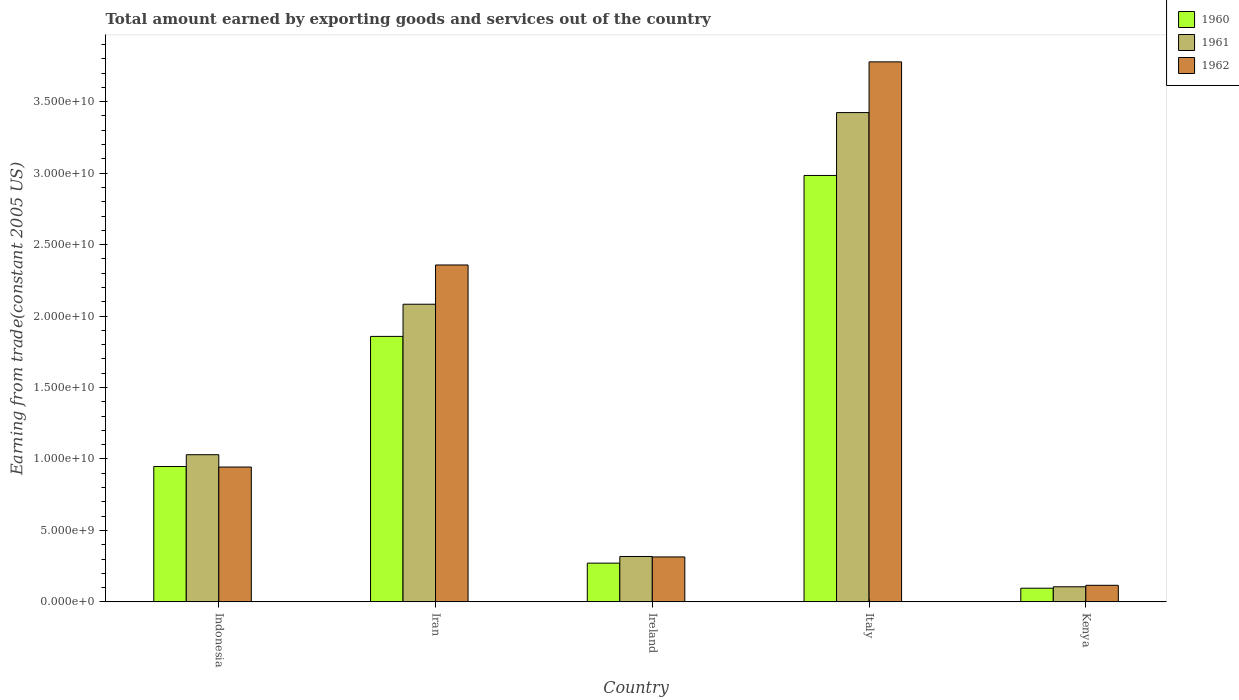How many different coloured bars are there?
Offer a very short reply. 3. How many groups of bars are there?
Offer a very short reply. 5. Are the number of bars on each tick of the X-axis equal?
Offer a very short reply. Yes. How many bars are there on the 4th tick from the right?
Offer a terse response. 3. What is the label of the 3rd group of bars from the left?
Your answer should be very brief. Ireland. What is the total amount earned by exporting goods and services in 1960 in Indonesia?
Make the answer very short. 9.47e+09. Across all countries, what is the maximum total amount earned by exporting goods and services in 1961?
Give a very brief answer. 3.42e+1. Across all countries, what is the minimum total amount earned by exporting goods and services in 1962?
Keep it short and to the point. 1.16e+09. In which country was the total amount earned by exporting goods and services in 1960 maximum?
Keep it short and to the point. Italy. In which country was the total amount earned by exporting goods and services in 1961 minimum?
Ensure brevity in your answer.  Kenya. What is the total total amount earned by exporting goods and services in 1960 in the graph?
Offer a very short reply. 6.16e+1. What is the difference between the total amount earned by exporting goods and services in 1962 in Iran and that in Kenya?
Your answer should be very brief. 2.24e+1. What is the difference between the total amount earned by exporting goods and services in 1961 in Italy and the total amount earned by exporting goods and services in 1960 in Ireland?
Your answer should be very brief. 3.15e+1. What is the average total amount earned by exporting goods and services in 1961 per country?
Make the answer very short. 1.39e+1. What is the difference between the total amount earned by exporting goods and services of/in 1960 and total amount earned by exporting goods and services of/in 1961 in Indonesia?
Make the answer very short. -8.26e+08. What is the ratio of the total amount earned by exporting goods and services in 1960 in Indonesia to that in Kenya?
Your answer should be compact. 9.91. What is the difference between the highest and the second highest total amount earned by exporting goods and services in 1961?
Ensure brevity in your answer.  1.05e+1. What is the difference between the highest and the lowest total amount earned by exporting goods and services in 1961?
Your answer should be compact. 3.32e+1. What does the 2nd bar from the right in Kenya represents?
Offer a terse response. 1961. Is it the case that in every country, the sum of the total amount earned by exporting goods and services in 1960 and total amount earned by exporting goods and services in 1961 is greater than the total amount earned by exporting goods and services in 1962?
Offer a terse response. Yes. How many bars are there?
Give a very brief answer. 15. Are all the bars in the graph horizontal?
Your response must be concise. No. How many countries are there in the graph?
Provide a short and direct response. 5. What is the difference between two consecutive major ticks on the Y-axis?
Provide a succinct answer. 5.00e+09. Does the graph contain grids?
Ensure brevity in your answer.  No. How are the legend labels stacked?
Make the answer very short. Vertical. What is the title of the graph?
Offer a terse response. Total amount earned by exporting goods and services out of the country. What is the label or title of the X-axis?
Your response must be concise. Country. What is the label or title of the Y-axis?
Keep it short and to the point. Earning from trade(constant 2005 US). What is the Earning from trade(constant 2005 US) in 1960 in Indonesia?
Provide a succinct answer. 9.47e+09. What is the Earning from trade(constant 2005 US) in 1961 in Indonesia?
Keep it short and to the point. 1.03e+1. What is the Earning from trade(constant 2005 US) of 1962 in Indonesia?
Your answer should be very brief. 9.44e+09. What is the Earning from trade(constant 2005 US) in 1960 in Iran?
Provide a succinct answer. 1.86e+1. What is the Earning from trade(constant 2005 US) of 1961 in Iran?
Offer a terse response. 2.08e+1. What is the Earning from trade(constant 2005 US) in 1962 in Iran?
Your response must be concise. 2.36e+1. What is the Earning from trade(constant 2005 US) in 1960 in Ireland?
Your response must be concise. 2.71e+09. What is the Earning from trade(constant 2005 US) in 1961 in Ireland?
Ensure brevity in your answer.  3.18e+09. What is the Earning from trade(constant 2005 US) of 1962 in Ireland?
Provide a succinct answer. 3.14e+09. What is the Earning from trade(constant 2005 US) of 1960 in Italy?
Provide a short and direct response. 2.98e+1. What is the Earning from trade(constant 2005 US) of 1961 in Italy?
Give a very brief answer. 3.42e+1. What is the Earning from trade(constant 2005 US) in 1962 in Italy?
Your answer should be compact. 3.78e+1. What is the Earning from trade(constant 2005 US) of 1960 in Kenya?
Give a very brief answer. 9.56e+08. What is the Earning from trade(constant 2005 US) of 1961 in Kenya?
Your answer should be very brief. 1.06e+09. What is the Earning from trade(constant 2005 US) of 1962 in Kenya?
Provide a short and direct response. 1.16e+09. Across all countries, what is the maximum Earning from trade(constant 2005 US) of 1960?
Keep it short and to the point. 2.98e+1. Across all countries, what is the maximum Earning from trade(constant 2005 US) of 1961?
Offer a terse response. 3.42e+1. Across all countries, what is the maximum Earning from trade(constant 2005 US) of 1962?
Provide a succinct answer. 3.78e+1. Across all countries, what is the minimum Earning from trade(constant 2005 US) of 1960?
Offer a terse response. 9.56e+08. Across all countries, what is the minimum Earning from trade(constant 2005 US) of 1961?
Your answer should be very brief. 1.06e+09. Across all countries, what is the minimum Earning from trade(constant 2005 US) of 1962?
Your answer should be compact. 1.16e+09. What is the total Earning from trade(constant 2005 US) of 1960 in the graph?
Provide a succinct answer. 6.16e+1. What is the total Earning from trade(constant 2005 US) in 1961 in the graph?
Offer a terse response. 6.96e+1. What is the total Earning from trade(constant 2005 US) of 1962 in the graph?
Give a very brief answer. 7.51e+1. What is the difference between the Earning from trade(constant 2005 US) of 1960 in Indonesia and that in Iran?
Your response must be concise. -9.10e+09. What is the difference between the Earning from trade(constant 2005 US) in 1961 in Indonesia and that in Iran?
Ensure brevity in your answer.  -1.05e+1. What is the difference between the Earning from trade(constant 2005 US) in 1962 in Indonesia and that in Iran?
Ensure brevity in your answer.  -1.41e+1. What is the difference between the Earning from trade(constant 2005 US) of 1960 in Indonesia and that in Ireland?
Your answer should be compact. 6.76e+09. What is the difference between the Earning from trade(constant 2005 US) of 1961 in Indonesia and that in Ireland?
Provide a short and direct response. 7.12e+09. What is the difference between the Earning from trade(constant 2005 US) of 1962 in Indonesia and that in Ireland?
Make the answer very short. 6.29e+09. What is the difference between the Earning from trade(constant 2005 US) in 1960 in Indonesia and that in Italy?
Make the answer very short. -2.04e+1. What is the difference between the Earning from trade(constant 2005 US) of 1961 in Indonesia and that in Italy?
Ensure brevity in your answer.  -2.39e+1. What is the difference between the Earning from trade(constant 2005 US) of 1962 in Indonesia and that in Italy?
Your answer should be very brief. -2.84e+1. What is the difference between the Earning from trade(constant 2005 US) of 1960 in Indonesia and that in Kenya?
Offer a very short reply. 8.52e+09. What is the difference between the Earning from trade(constant 2005 US) in 1961 in Indonesia and that in Kenya?
Your response must be concise. 9.24e+09. What is the difference between the Earning from trade(constant 2005 US) of 1962 in Indonesia and that in Kenya?
Your answer should be very brief. 8.28e+09. What is the difference between the Earning from trade(constant 2005 US) of 1960 in Iran and that in Ireland?
Give a very brief answer. 1.59e+1. What is the difference between the Earning from trade(constant 2005 US) of 1961 in Iran and that in Ireland?
Give a very brief answer. 1.77e+1. What is the difference between the Earning from trade(constant 2005 US) of 1962 in Iran and that in Ireland?
Your answer should be compact. 2.04e+1. What is the difference between the Earning from trade(constant 2005 US) in 1960 in Iran and that in Italy?
Provide a succinct answer. -1.13e+1. What is the difference between the Earning from trade(constant 2005 US) in 1961 in Iran and that in Italy?
Make the answer very short. -1.34e+1. What is the difference between the Earning from trade(constant 2005 US) of 1962 in Iran and that in Italy?
Keep it short and to the point. -1.42e+1. What is the difference between the Earning from trade(constant 2005 US) of 1960 in Iran and that in Kenya?
Make the answer very short. 1.76e+1. What is the difference between the Earning from trade(constant 2005 US) of 1961 in Iran and that in Kenya?
Provide a succinct answer. 1.98e+1. What is the difference between the Earning from trade(constant 2005 US) of 1962 in Iran and that in Kenya?
Provide a succinct answer. 2.24e+1. What is the difference between the Earning from trade(constant 2005 US) of 1960 in Ireland and that in Italy?
Provide a succinct answer. -2.71e+1. What is the difference between the Earning from trade(constant 2005 US) in 1961 in Ireland and that in Italy?
Your response must be concise. -3.11e+1. What is the difference between the Earning from trade(constant 2005 US) in 1962 in Ireland and that in Italy?
Provide a succinct answer. -3.46e+1. What is the difference between the Earning from trade(constant 2005 US) in 1960 in Ireland and that in Kenya?
Keep it short and to the point. 1.75e+09. What is the difference between the Earning from trade(constant 2005 US) of 1961 in Ireland and that in Kenya?
Offer a very short reply. 2.12e+09. What is the difference between the Earning from trade(constant 2005 US) in 1962 in Ireland and that in Kenya?
Make the answer very short. 1.98e+09. What is the difference between the Earning from trade(constant 2005 US) of 1960 in Italy and that in Kenya?
Keep it short and to the point. 2.89e+1. What is the difference between the Earning from trade(constant 2005 US) of 1961 in Italy and that in Kenya?
Offer a very short reply. 3.32e+1. What is the difference between the Earning from trade(constant 2005 US) in 1962 in Italy and that in Kenya?
Provide a short and direct response. 3.66e+1. What is the difference between the Earning from trade(constant 2005 US) of 1960 in Indonesia and the Earning from trade(constant 2005 US) of 1961 in Iran?
Make the answer very short. -1.14e+1. What is the difference between the Earning from trade(constant 2005 US) in 1960 in Indonesia and the Earning from trade(constant 2005 US) in 1962 in Iran?
Offer a very short reply. -1.41e+1. What is the difference between the Earning from trade(constant 2005 US) in 1961 in Indonesia and the Earning from trade(constant 2005 US) in 1962 in Iran?
Your answer should be very brief. -1.33e+1. What is the difference between the Earning from trade(constant 2005 US) of 1960 in Indonesia and the Earning from trade(constant 2005 US) of 1961 in Ireland?
Offer a very short reply. 6.30e+09. What is the difference between the Earning from trade(constant 2005 US) in 1960 in Indonesia and the Earning from trade(constant 2005 US) in 1962 in Ireland?
Keep it short and to the point. 6.33e+09. What is the difference between the Earning from trade(constant 2005 US) of 1961 in Indonesia and the Earning from trade(constant 2005 US) of 1962 in Ireland?
Provide a succinct answer. 7.15e+09. What is the difference between the Earning from trade(constant 2005 US) of 1960 in Indonesia and the Earning from trade(constant 2005 US) of 1961 in Italy?
Your answer should be compact. -2.48e+1. What is the difference between the Earning from trade(constant 2005 US) in 1960 in Indonesia and the Earning from trade(constant 2005 US) in 1962 in Italy?
Make the answer very short. -2.83e+1. What is the difference between the Earning from trade(constant 2005 US) of 1961 in Indonesia and the Earning from trade(constant 2005 US) of 1962 in Italy?
Ensure brevity in your answer.  -2.75e+1. What is the difference between the Earning from trade(constant 2005 US) in 1960 in Indonesia and the Earning from trade(constant 2005 US) in 1961 in Kenya?
Your answer should be compact. 8.42e+09. What is the difference between the Earning from trade(constant 2005 US) of 1960 in Indonesia and the Earning from trade(constant 2005 US) of 1962 in Kenya?
Provide a short and direct response. 8.31e+09. What is the difference between the Earning from trade(constant 2005 US) in 1961 in Indonesia and the Earning from trade(constant 2005 US) in 1962 in Kenya?
Your answer should be compact. 9.14e+09. What is the difference between the Earning from trade(constant 2005 US) of 1960 in Iran and the Earning from trade(constant 2005 US) of 1961 in Ireland?
Offer a very short reply. 1.54e+1. What is the difference between the Earning from trade(constant 2005 US) in 1960 in Iran and the Earning from trade(constant 2005 US) in 1962 in Ireland?
Provide a succinct answer. 1.54e+1. What is the difference between the Earning from trade(constant 2005 US) in 1961 in Iran and the Earning from trade(constant 2005 US) in 1962 in Ireland?
Offer a very short reply. 1.77e+1. What is the difference between the Earning from trade(constant 2005 US) of 1960 in Iran and the Earning from trade(constant 2005 US) of 1961 in Italy?
Offer a very short reply. -1.57e+1. What is the difference between the Earning from trade(constant 2005 US) in 1960 in Iran and the Earning from trade(constant 2005 US) in 1962 in Italy?
Your response must be concise. -1.92e+1. What is the difference between the Earning from trade(constant 2005 US) in 1961 in Iran and the Earning from trade(constant 2005 US) in 1962 in Italy?
Make the answer very short. -1.70e+1. What is the difference between the Earning from trade(constant 2005 US) in 1960 in Iran and the Earning from trade(constant 2005 US) in 1961 in Kenya?
Make the answer very short. 1.75e+1. What is the difference between the Earning from trade(constant 2005 US) of 1960 in Iran and the Earning from trade(constant 2005 US) of 1962 in Kenya?
Give a very brief answer. 1.74e+1. What is the difference between the Earning from trade(constant 2005 US) in 1961 in Iran and the Earning from trade(constant 2005 US) in 1962 in Kenya?
Give a very brief answer. 1.97e+1. What is the difference between the Earning from trade(constant 2005 US) of 1960 in Ireland and the Earning from trade(constant 2005 US) of 1961 in Italy?
Your answer should be compact. -3.15e+1. What is the difference between the Earning from trade(constant 2005 US) in 1960 in Ireland and the Earning from trade(constant 2005 US) in 1962 in Italy?
Keep it short and to the point. -3.51e+1. What is the difference between the Earning from trade(constant 2005 US) in 1961 in Ireland and the Earning from trade(constant 2005 US) in 1962 in Italy?
Your answer should be very brief. -3.46e+1. What is the difference between the Earning from trade(constant 2005 US) of 1960 in Ireland and the Earning from trade(constant 2005 US) of 1961 in Kenya?
Your response must be concise. 1.65e+09. What is the difference between the Earning from trade(constant 2005 US) in 1960 in Ireland and the Earning from trade(constant 2005 US) in 1962 in Kenya?
Your answer should be very brief. 1.55e+09. What is the difference between the Earning from trade(constant 2005 US) of 1961 in Ireland and the Earning from trade(constant 2005 US) of 1962 in Kenya?
Offer a terse response. 2.02e+09. What is the difference between the Earning from trade(constant 2005 US) of 1960 in Italy and the Earning from trade(constant 2005 US) of 1961 in Kenya?
Give a very brief answer. 2.88e+1. What is the difference between the Earning from trade(constant 2005 US) in 1960 in Italy and the Earning from trade(constant 2005 US) in 1962 in Kenya?
Your answer should be very brief. 2.87e+1. What is the difference between the Earning from trade(constant 2005 US) in 1961 in Italy and the Earning from trade(constant 2005 US) in 1962 in Kenya?
Provide a succinct answer. 3.31e+1. What is the average Earning from trade(constant 2005 US) of 1960 per country?
Offer a terse response. 1.23e+1. What is the average Earning from trade(constant 2005 US) of 1961 per country?
Give a very brief answer. 1.39e+1. What is the average Earning from trade(constant 2005 US) in 1962 per country?
Your response must be concise. 1.50e+1. What is the difference between the Earning from trade(constant 2005 US) of 1960 and Earning from trade(constant 2005 US) of 1961 in Indonesia?
Provide a succinct answer. -8.26e+08. What is the difference between the Earning from trade(constant 2005 US) in 1960 and Earning from trade(constant 2005 US) in 1962 in Indonesia?
Keep it short and to the point. 3.67e+07. What is the difference between the Earning from trade(constant 2005 US) of 1961 and Earning from trade(constant 2005 US) of 1962 in Indonesia?
Your response must be concise. 8.63e+08. What is the difference between the Earning from trade(constant 2005 US) of 1960 and Earning from trade(constant 2005 US) of 1961 in Iran?
Make the answer very short. -2.25e+09. What is the difference between the Earning from trade(constant 2005 US) in 1960 and Earning from trade(constant 2005 US) in 1962 in Iran?
Ensure brevity in your answer.  -5.00e+09. What is the difference between the Earning from trade(constant 2005 US) in 1961 and Earning from trade(constant 2005 US) in 1962 in Iran?
Keep it short and to the point. -2.75e+09. What is the difference between the Earning from trade(constant 2005 US) of 1960 and Earning from trade(constant 2005 US) of 1961 in Ireland?
Your answer should be compact. -4.66e+08. What is the difference between the Earning from trade(constant 2005 US) in 1960 and Earning from trade(constant 2005 US) in 1962 in Ireland?
Provide a short and direct response. -4.33e+08. What is the difference between the Earning from trade(constant 2005 US) in 1961 and Earning from trade(constant 2005 US) in 1962 in Ireland?
Make the answer very short. 3.26e+07. What is the difference between the Earning from trade(constant 2005 US) of 1960 and Earning from trade(constant 2005 US) of 1961 in Italy?
Provide a short and direct response. -4.40e+09. What is the difference between the Earning from trade(constant 2005 US) in 1960 and Earning from trade(constant 2005 US) in 1962 in Italy?
Your answer should be very brief. -7.95e+09. What is the difference between the Earning from trade(constant 2005 US) of 1961 and Earning from trade(constant 2005 US) of 1962 in Italy?
Make the answer very short. -3.55e+09. What is the difference between the Earning from trade(constant 2005 US) of 1960 and Earning from trade(constant 2005 US) of 1961 in Kenya?
Make the answer very short. -1.01e+08. What is the difference between the Earning from trade(constant 2005 US) of 1960 and Earning from trade(constant 2005 US) of 1962 in Kenya?
Give a very brief answer. -2.04e+08. What is the difference between the Earning from trade(constant 2005 US) of 1961 and Earning from trade(constant 2005 US) of 1962 in Kenya?
Provide a short and direct response. -1.03e+08. What is the ratio of the Earning from trade(constant 2005 US) in 1960 in Indonesia to that in Iran?
Provide a short and direct response. 0.51. What is the ratio of the Earning from trade(constant 2005 US) in 1961 in Indonesia to that in Iran?
Your answer should be compact. 0.49. What is the ratio of the Earning from trade(constant 2005 US) of 1962 in Indonesia to that in Iran?
Your answer should be very brief. 0.4. What is the ratio of the Earning from trade(constant 2005 US) in 1960 in Indonesia to that in Ireland?
Offer a terse response. 3.49. What is the ratio of the Earning from trade(constant 2005 US) of 1961 in Indonesia to that in Ireland?
Your answer should be compact. 3.24. What is the ratio of the Earning from trade(constant 2005 US) of 1962 in Indonesia to that in Ireland?
Provide a succinct answer. 3. What is the ratio of the Earning from trade(constant 2005 US) in 1960 in Indonesia to that in Italy?
Offer a very short reply. 0.32. What is the ratio of the Earning from trade(constant 2005 US) of 1961 in Indonesia to that in Italy?
Your answer should be compact. 0.3. What is the ratio of the Earning from trade(constant 2005 US) of 1962 in Indonesia to that in Italy?
Your answer should be very brief. 0.25. What is the ratio of the Earning from trade(constant 2005 US) in 1960 in Indonesia to that in Kenya?
Provide a succinct answer. 9.91. What is the ratio of the Earning from trade(constant 2005 US) in 1961 in Indonesia to that in Kenya?
Provide a short and direct response. 9.75. What is the ratio of the Earning from trade(constant 2005 US) of 1962 in Indonesia to that in Kenya?
Make the answer very short. 8.14. What is the ratio of the Earning from trade(constant 2005 US) in 1960 in Iran to that in Ireland?
Make the answer very short. 6.85. What is the ratio of the Earning from trade(constant 2005 US) in 1961 in Iran to that in Ireland?
Offer a very short reply. 6.56. What is the ratio of the Earning from trade(constant 2005 US) of 1962 in Iran to that in Ireland?
Your answer should be very brief. 7.5. What is the ratio of the Earning from trade(constant 2005 US) in 1960 in Iran to that in Italy?
Make the answer very short. 0.62. What is the ratio of the Earning from trade(constant 2005 US) in 1961 in Iran to that in Italy?
Your response must be concise. 0.61. What is the ratio of the Earning from trade(constant 2005 US) of 1962 in Iran to that in Italy?
Provide a succinct answer. 0.62. What is the ratio of the Earning from trade(constant 2005 US) in 1960 in Iran to that in Kenya?
Offer a terse response. 19.44. What is the ratio of the Earning from trade(constant 2005 US) of 1961 in Iran to that in Kenya?
Offer a terse response. 19.71. What is the ratio of the Earning from trade(constant 2005 US) of 1962 in Iran to that in Kenya?
Make the answer very short. 20.33. What is the ratio of the Earning from trade(constant 2005 US) of 1960 in Ireland to that in Italy?
Offer a terse response. 0.09. What is the ratio of the Earning from trade(constant 2005 US) in 1961 in Ireland to that in Italy?
Ensure brevity in your answer.  0.09. What is the ratio of the Earning from trade(constant 2005 US) of 1962 in Ireland to that in Italy?
Ensure brevity in your answer.  0.08. What is the ratio of the Earning from trade(constant 2005 US) of 1960 in Ireland to that in Kenya?
Ensure brevity in your answer.  2.84. What is the ratio of the Earning from trade(constant 2005 US) of 1961 in Ireland to that in Kenya?
Ensure brevity in your answer.  3.01. What is the ratio of the Earning from trade(constant 2005 US) in 1962 in Ireland to that in Kenya?
Keep it short and to the point. 2.71. What is the ratio of the Earning from trade(constant 2005 US) in 1960 in Italy to that in Kenya?
Your answer should be compact. 31.22. What is the ratio of the Earning from trade(constant 2005 US) in 1961 in Italy to that in Kenya?
Give a very brief answer. 32.41. What is the ratio of the Earning from trade(constant 2005 US) in 1962 in Italy to that in Kenya?
Your answer should be very brief. 32.58. What is the difference between the highest and the second highest Earning from trade(constant 2005 US) in 1960?
Your response must be concise. 1.13e+1. What is the difference between the highest and the second highest Earning from trade(constant 2005 US) of 1961?
Provide a succinct answer. 1.34e+1. What is the difference between the highest and the second highest Earning from trade(constant 2005 US) in 1962?
Ensure brevity in your answer.  1.42e+1. What is the difference between the highest and the lowest Earning from trade(constant 2005 US) of 1960?
Your answer should be very brief. 2.89e+1. What is the difference between the highest and the lowest Earning from trade(constant 2005 US) in 1961?
Ensure brevity in your answer.  3.32e+1. What is the difference between the highest and the lowest Earning from trade(constant 2005 US) in 1962?
Offer a very short reply. 3.66e+1. 